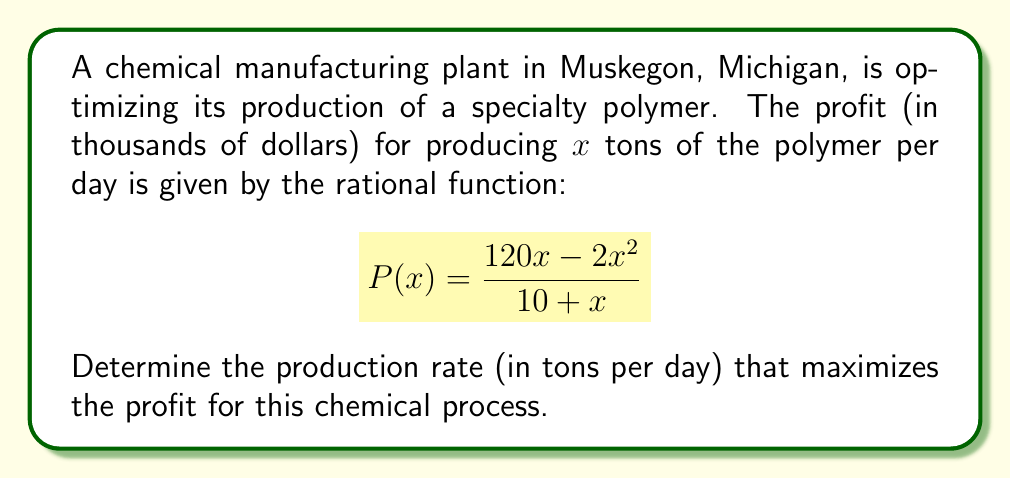Solve this math problem. To find the optimal production rate, we need to find the maximum value of the profit function P(x). This can be done by following these steps:

1) First, we need to find the derivative of P(x):

   $$P'(x) = \frac{(120x - 2x^2)'(10 + x) - (120x - 2x^2)(10 + x)'}{(10 + x)^2}$$

2) Simplify:

   $$P'(x) = \frac{(120 - 4x)(10 + x) - (120x - 2x^2)(1)}{(10 + x)^2}$$

3) Expand:

   $$P'(x) = \frac{1200 + 120x - 40x - 4x^2 - 120x + 2x^2}{(10 + x)^2}$$

4) Simplify further:

   $$P'(x) = \frac{1200 - 2x^2}{(10 + x)^2}$$

5) To find the maximum, set P'(x) = 0:

   $$\frac{1200 - 2x^2}{(10 + x)^2} = 0$$

6) Solve for x:

   $1200 - 2x^2 = 0$
   $2x^2 = 1200$
   $x^2 = 600$
   $x = \sqrt{600} \approx 24.49$

7) Verify this is a maximum by checking the second derivative is negative at this point (omitted for brevity).

8) Round to the nearest whole number, as production rate is likely measured in whole tons.

Therefore, the optimal production rate is 24 tons per day.
Answer: 24 tons per day 